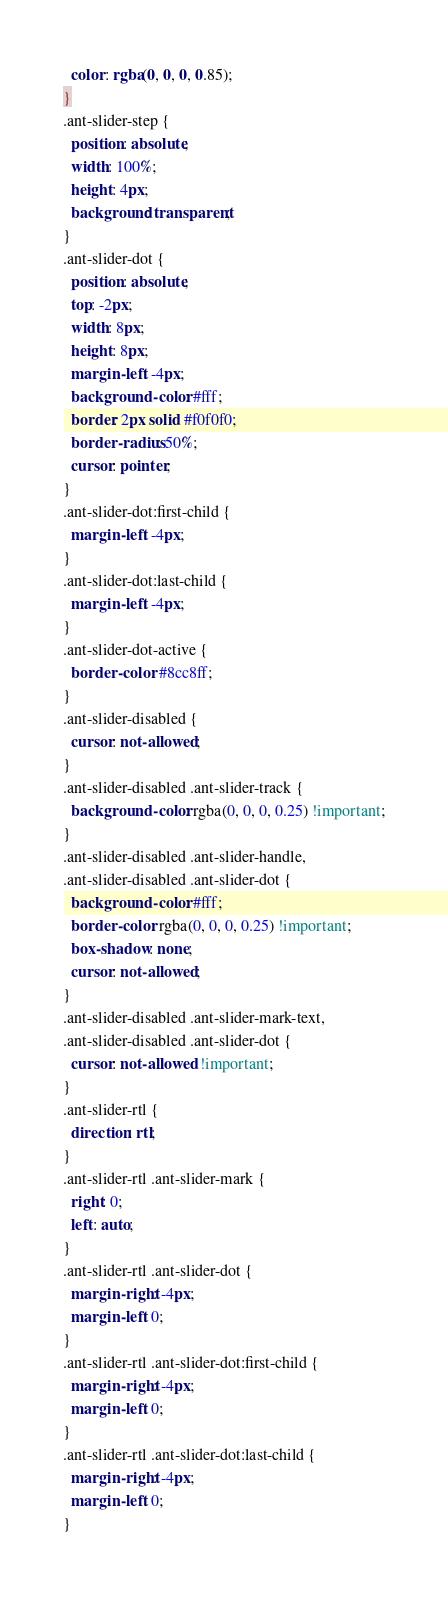<code> <loc_0><loc_0><loc_500><loc_500><_CSS_>  color: rgba(0, 0, 0, 0.85);
}
.ant-slider-step {
  position: absolute;
  width: 100%;
  height: 4px;
  background: transparent;
}
.ant-slider-dot {
  position: absolute;
  top: -2px;
  width: 8px;
  height: 8px;
  margin-left: -4px;
  background-color: #fff;
  border: 2px solid #f0f0f0;
  border-radius: 50%;
  cursor: pointer;
}
.ant-slider-dot:first-child {
  margin-left: -4px;
}
.ant-slider-dot:last-child {
  margin-left: -4px;
}
.ant-slider-dot-active {
  border-color: #8cc8ff;
}
.ant-slider-disabled {
  cursor: not-allowed;
}
.ant-slider-disabled .ant-slider-track {
  background-color: rgba(0, 0, 0, 0.25) !important;
}
.ant-slider-disabled .ant-slider-handle,
.ant-slider-disabled .ant-slider-dot {
  background-color: #fff;
  border-color: rgba(0, 0, 0, 0.25) !important;
  box-shadow: none;
  cursor: not-allowed;
}
.ant-slider-disabled .ant-slider-mark-text,
.ant-slider-disabled .ant-slider-dot {
  cursor: not-allowed !important;
}
.ant-slider-rtl {
  direction: rtl;
}
.ant-slider-rtl .ant-slider-mark {
  right: 0;
  left: auto;
}
.ant-slider-rtl .ant-slider-dot {
  margin-right: -4px;
  margin-left: 0;
}
.ant-slider-rtl .ant-slider-dot:first-child {
  margin-right: -4px;
  margin-left: 0;
}
.ant-slider-rtl .ant-slider-dot:last-child {
  margin-right: -4px;
  margin-left: 0;
}
</code> 